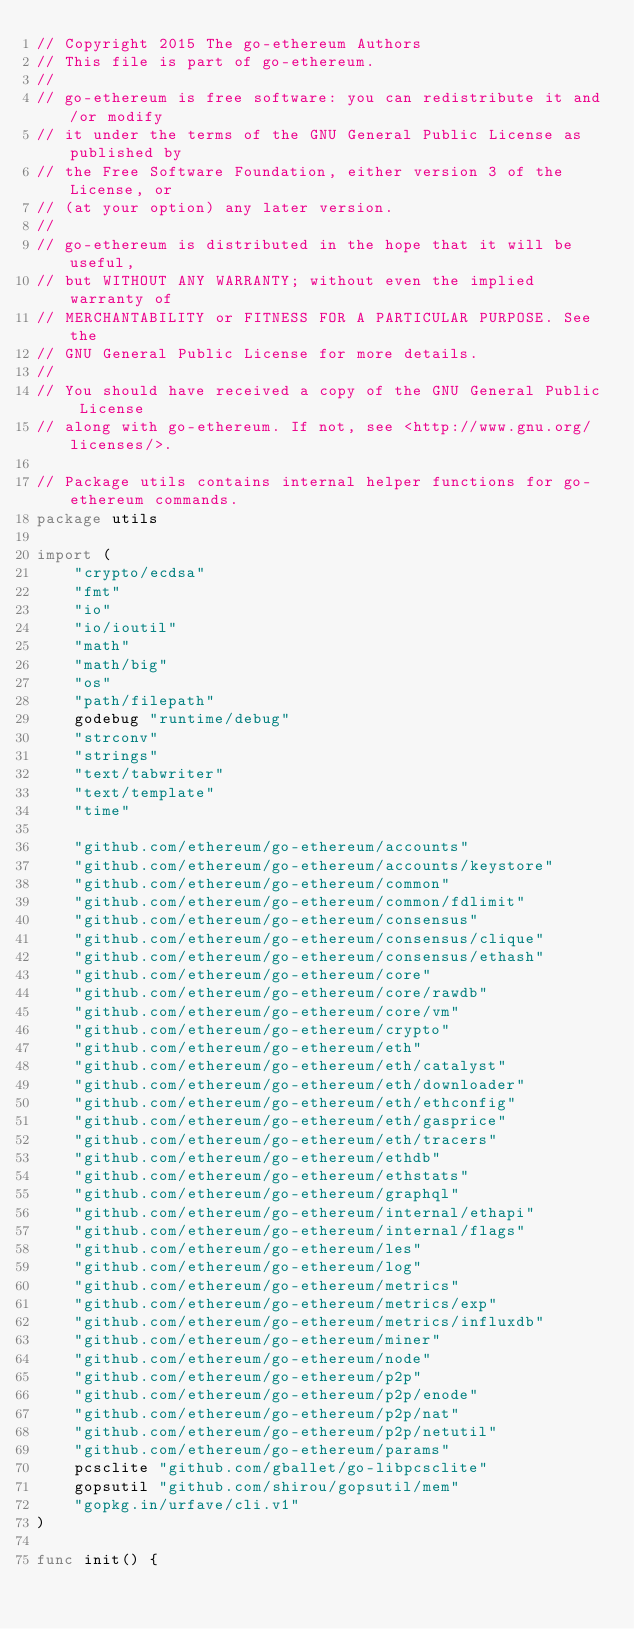Convert code to text. <code><loc_0><loc_0><loc_500><loc_500><_Go_>// Copyright 2015 The go-ethereum Authors
// This file is part of go-ethereum.
//
// go-ethereum is free software: you can redistribute it and/or modify
// it under the terms of the GNU General Public License as published by
// the Free Software Foundation, either version 3 of the License, or
// (at your option) any later version.
//
// go-ethereum is distributed in the hope that it will be useful,
// but WITHOUT ANY WARRANTY; without even the implied warranty of
// MERCHANTABILITY or FITNESS FOR A PARTICULAR PURPOSE. See the
// GNU General Public License for more details.
//
// You should have received a copy of the GNU General Public License
// along with go-ethereum. If not, see <http://www.gnu.org/licenses/>.

// Package utils contains internal helper functions for go-ethereum commands.
package utils

import (
	"crypto/ecdsa"
	"fmt"
	"io"
	"io/ioutil"
	"math"
	"math/big"
	"os"
	"path/filepath"
	godebug "runtime/debug"
	"strconv"
	"strings"
	"text/tabwriter"
	"text/template"
	"time"

	"github.com/ethereum/go-ethereum/accounts"
	"github.com/ethereum/go-ethereum/accounts/keystore"
	"github.com/ethereum/go-ethereum/common"
	"github.com/ethereum/go-ethereum/common/fdlimit"
	"github.com/ethereum/go-ethereum/consensus"
	"github.com/ethereum/go-ethereum/consensus/clique"
	"github.com/ethereum/go-ethereum/consensus/ethash"
	"github.com/ethereum/go-ethereum/core"
	"github.com/ethereum/go-ethereum/core/rawdb"
	"github.com/ethereum/go-ethereum/core/vm"
	"github.com/ethereum/go-ethereum/crypto"
	"github.com/ethereum/go-ethereum/eth"
	"github.com/ethereum/go-ethereum/eth/catalyst"
	"github.com/ethereum/go-ethereum/eth/downloader"
	"github.com/ethereum/go-ethereum/eth/ethconfig"
	"github.com/ethereum/go-ethereum/eth/gasprice"
	"github.com/ethereum/go-ethereum/eth/tracers"
	"github.com/ethereum/go-ethereum/ethdb"
	"github.com/ethereum/go-ethereum/ethstats"
	"github.com/ethereum/go-ethereum/graphql"
	"github.com/ethereum/go-ethereum/internal/ethapi"
	"github.com/ethereum/go-ethereum/internal/flags"
	"github.com/ethereum/go-ethereum/les"
	"github.com/ethereum/go-ethereum/log"
	"github.com/ethereum/go-ethereum/metrics"
	"github.com/ethereum/go-ethereum/metrics/exp"
	"github.com/ethereum/go-ethereum/metrics/influxdb"
	"github.com/ethereum/go-ethereum/miner"
	"github.com/ethereum/go-ethereum/node"
	"github.com/ethereum/go-ethereum/p2p"
	"github.com/ethereum/go-ethereum/p2p/enode"
	"github.com/ethereum/go-ethereum/p2p/nat"
	"github.com/ethereum/go-ethereum/p2p/netutil"
	"github.com/ethereum/go-ethereum/params"
	pcsclite "github.com/gballet/go-libpcsclite"
	gopsutil "github.com/shirou/gopsutil/mem"
	"gopkg.in/urfave/cli.v1"
)

func init() {</code> 